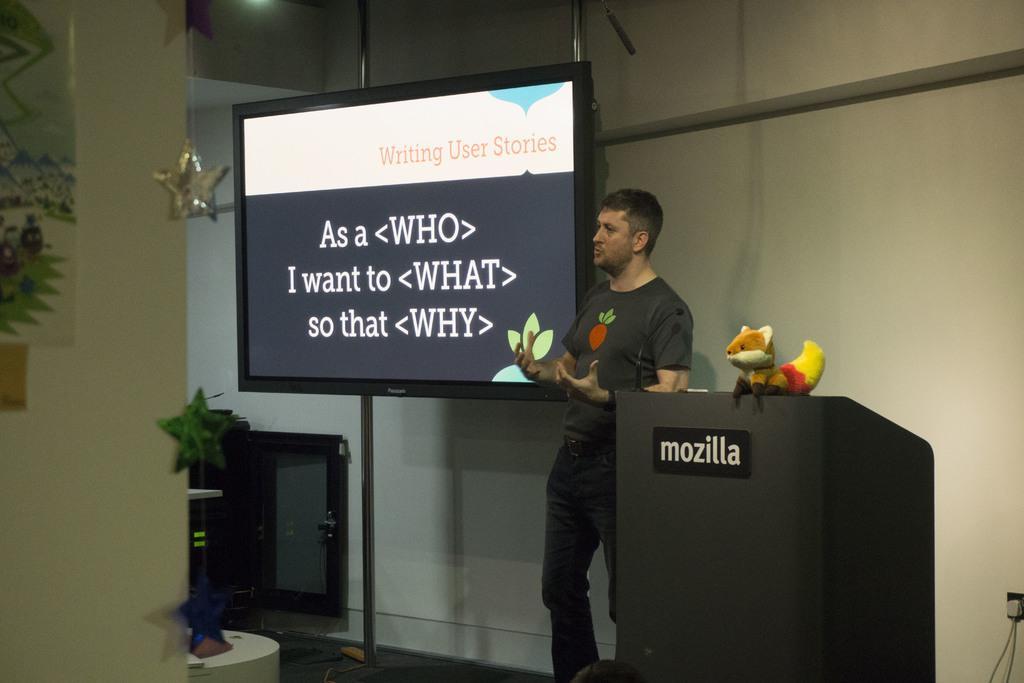Describe this image in one or two sentences. In this image I can see the person is standing. I can see the podium and toy on the podium. I can see the screen, few objects and white color background. 